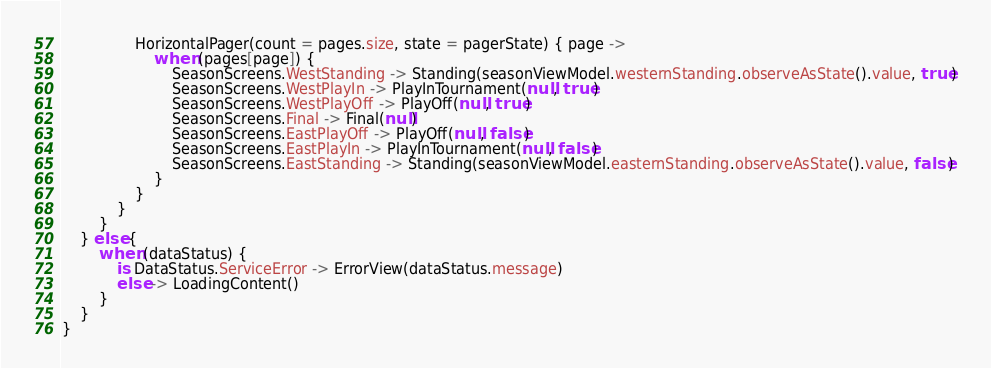<code> <loc_0><loc_0><loc_500><loc_500><_Kotlin_>
                HorizontalPager(count = pages.size, state = pagerState) { page ->
                    when (pages[page]) {
                        SeasonScreens.WestStanding -> Standing(seasonViewModel.westernStanding.observeAsState().value, true)
                        SeasonScreens.WestPlayIn -> PlayInTournament(null, true)
                        SeasonScreens.WestPlayOff -> PlayOff(null, true)
                        SeasonScreens.Final -> Final(null)
                        SeasonScreens.EastPlayOff -> PlayOff(null, false)
                        SeasonScreens.EastPlayIn -> PlayInTournament(null, false)
                        SeasonScreens.EastStanding -> Standing(seasonViewModel.easternStanding.observeAsState().value, false)
                    }
                }
            }
        }
    } else {
        when (dataStatus) {
            is DataStatus.ServiceError -> ErrorView(dataStatus.message)
            else -> LoadingContent()
        }
    }
}
</code> 